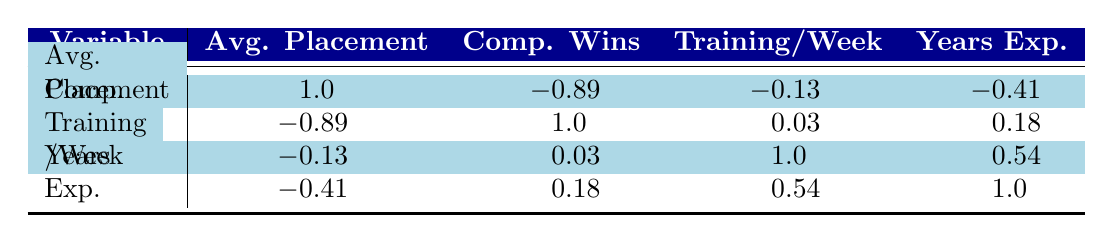What is the correlation between average placement and competition wins? The table shows a correlation coefficient of -0.89 between average placement and competition wins. This indicates a strong negative correlation, meaning as average placements improve (lower number), competition wins tend to decrease.
Answer: -0.89 Which athlete has the highest average placement? Looking at the average placement values for each athlete, Evelyn Green has the lowest average placement at 2.8, making her the athlete with the highest average placement.
Answer: Evelyn Green If two athletes have the same years of experience, does having more training sessions per week guarantee higher competition wins? The correlation coefficient between training sessions per week and competition wins is 0.03, which indicates almost no correlation. This means that having more training sessions does not guarantee higher competition wins, even if experience is the same.
Answer: No What is the average years of experience for the athletes in the dataset? We have the years of experience for each athlete: 10, 8, 12, 6, 7, and 9. Summing these gives 52, and dividing by the number of athletes (6) gives an average of approximately 8.67 years.
Answer: 8.67 Which athlete has the most competition wins, and what is their average placement? Sofia Chen has the most competition wins at 10. Her average placement is 2.5.
Answer: Sofia Chen, 2.5 What is the average of the average placements for all athletes? The average placements are 3.1, 2.8, 4.5, 3.5, 2.5, and 3.8. Summing these gives 20.4; dividing by 6 gives an average of approximately 3.4.
Answer: 3.4 Is there a positive correlation between years of experience and training sessions per week? The correlation coefficient between years of experience and training sessions per week is 0.54, indicating a moderate positive correlation. This means that generally, as years of experience increase, training sessions per week also tend to increase.
Answer: Yes If an athlete has an average placement of 4.5, can we expect them to have a high number of competition wins? The correlation coefficient between average placement and competition wins is -0.89, indicating a strong negative relationship. Hence, an athlete with an average placement of 4.5 would likely have relatively low competition wins.
Answer: No 